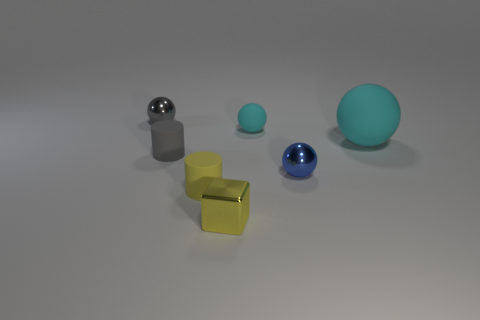What number of matte things are big blue cubes or yellow cubes?
Offer a very short reply. 0. Does the small gray thing that is in front of the gray ball have the same material as the tiny yellow object that is on the left side of the yellow shiny cube?
Provide a succinct answer. Yes. Is there a gray sphere?
Provide a succinct answer. Yes. There is a gray thing behind the small cyan ball; is its shape the same as the tiny matte object that is in front of the small blue ball?
Your answer should be very brief. No. Are there any small yellow objects that have the same material as the tiny gray cylinder?
Make the answer very short. Yes. Is the material of the gray thing that is to the right of the gray shiny object the same as the cube?
Your answer should be very brief. No. Is the number of tiny cyan matte objects that are to the left of the small gray cylinder greater than the number of yellow objects behind the large cyan rubber sphere?
Give a very brief answer. No. There is a matte ball that is the same size as the yellow cube; what is its color?
Make the answer very short. Cyan. Is there a big thing that has the same color as the large sphere?
Give a very brief answer. No. Do the small rubber thing that is in front of the blue sphere and the metal sphere that is right of the small yellow matte cylinder have the same color?
Your answer should be very brief. No. 